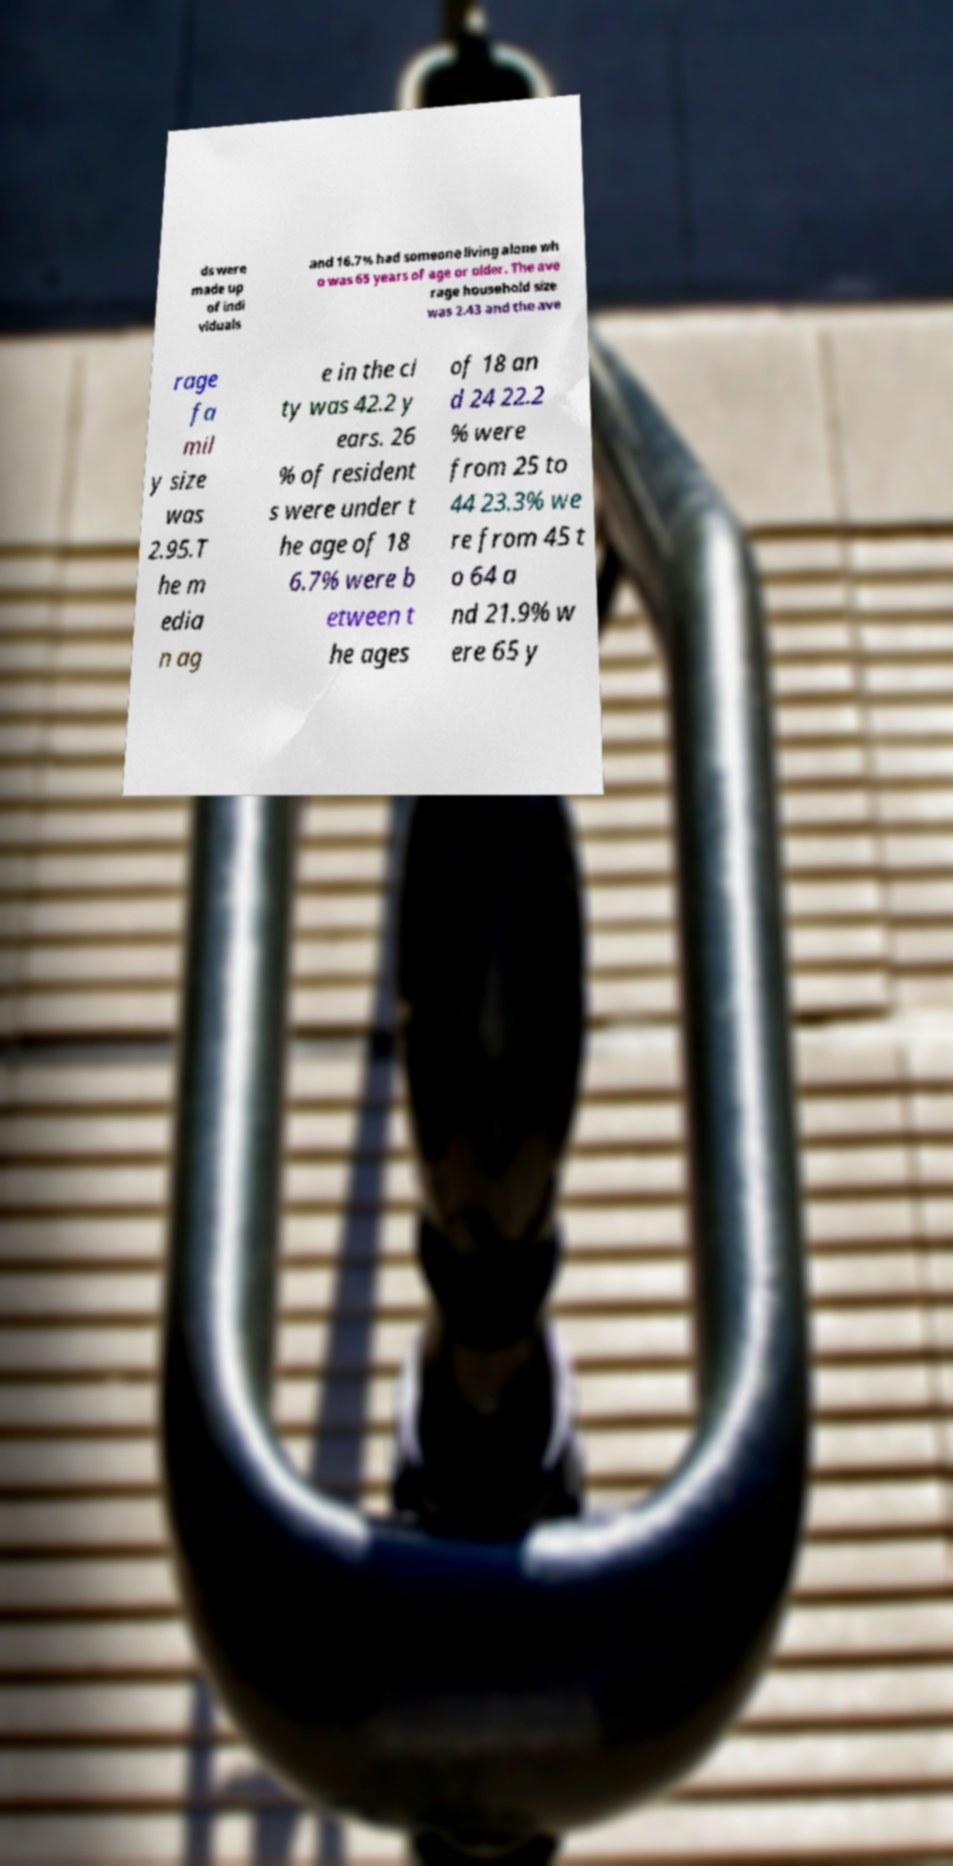What messages or text are displayed in this image? I need them in a readable, typed format. ds were made up of indi viduals and 16.7% had someone living alone wh o was 65 years of age or older. The ave rage household size was 2.43 and the ave rage fa mil y size was 2.95.T he m edia n ag e in the ci ty was 42.2 y ears. 26 % of resident s were under t he age of 18 6.7% were b etween t he ages of 18 an d 24 22.2 % were from 25 to 44 23.3% we re from 45 t o 64 a nd 21.9% w ere 65 y 